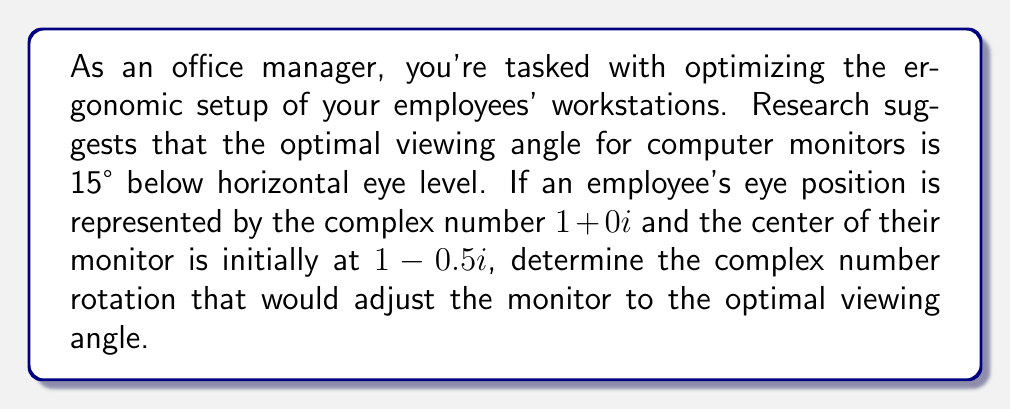What is the answer to this math problem? Let's approach this step-by-step:

1) First, we need to understand what the question is asking. We're dealing with a rotation in the complex plane, where the employee's eye is at $1+0i$ and the monitor is initially at $1-0.5i$.

2) The optimal viewing angle is 15° below horizontal eye level. In the complex plane, this means we need to rotate the vector from the eye to the monitor by 15° clockwise.

3) To rotate a vector in the complex plane, we multiply by $e^{-i\theta}$, where $\theta$ is the angle of rotation in radians. For a clockwise rotation, we use a negative angle.

4) We need to convert 15° to radians:
   $$15° \times \frac{\pi}{180°} = \frac{\pi}{12} \approx 0.2618$$

5) The vector from the eye to the monitor is:
   $$(1-0.5i) - (1+0i) = -0.5i$$

6) Now, we need to rotate this vector by multiplying it by $e^{-i\frac{\pi}{12}}$:
   $$-0.5i \times e^{-i\frac{\pi}{12}}$$

7) Using Euler's formula, $e^{-i\frac{\pi}{12}} = \cos(-\frac{\pi}{12}) + i\sin(-\frac{\pi}{12})$:
   $$-0.5i \times (\cos(\frac{\pi}{12}) - i\sin(\frac{\pi}{12}))$$

8) Multiplying this out:
   $$-0.5i\cos(\frac{\pi}{12}) + 0.5\sin(\frac{\pi}{12})$$

9) The rotated vector represents the new position of the monitor relative to the eye. To get the absolute position, we add this to the eye position:
   $$(1+0i) + (-0.5i\cos(\frac{\pi}{12}) + 0.5\sin(\frac{\pi}{12}))$$

10) Simplifying:
    $$1 + 0.5\sin(\frac{\pi}{12}) - 0.5i\cos(\frac{\pi}{12})$$

This is the complex number representing the optimal position of the monitor.
Answer: The optimal position of the monitor is represented by the complex number:
$$1 + 0.5\sin(\frac{\pi}{12}) - 0.5i\cos(\frac{\pi}{12}) \approx 1.0650 - 0.4830i$$ 